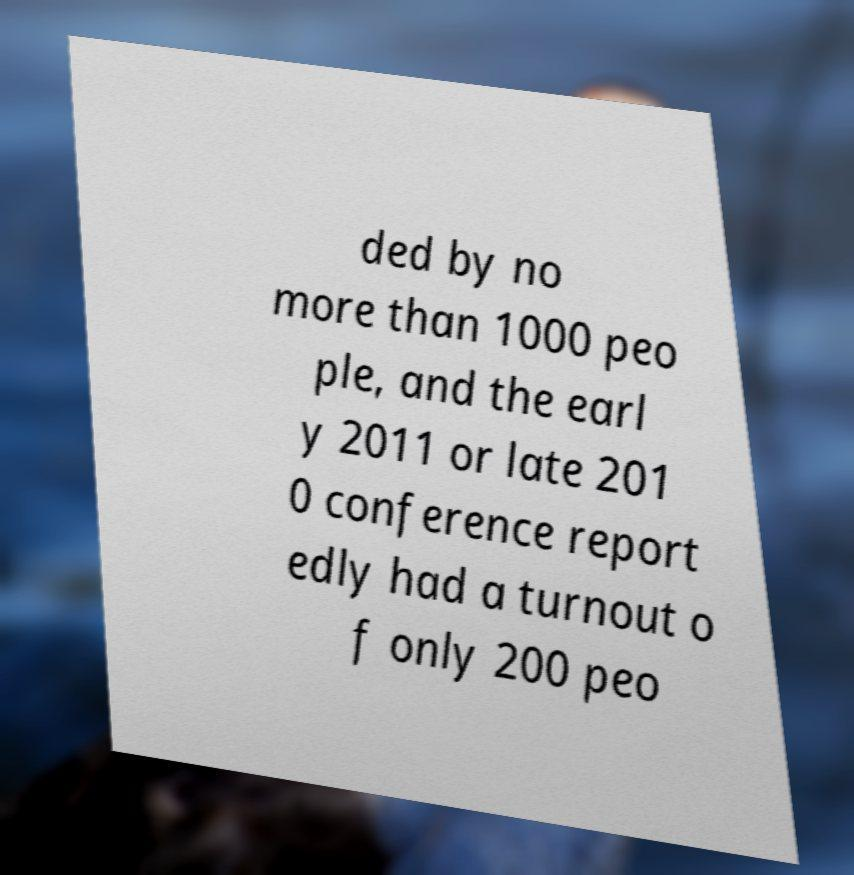Can you accurately transcribe the text from the provided image for me? ded by no more than 1000 peo ple, and the earl y 2011 or late 201 0 conference report edly had a turnout o f only 200 peo 